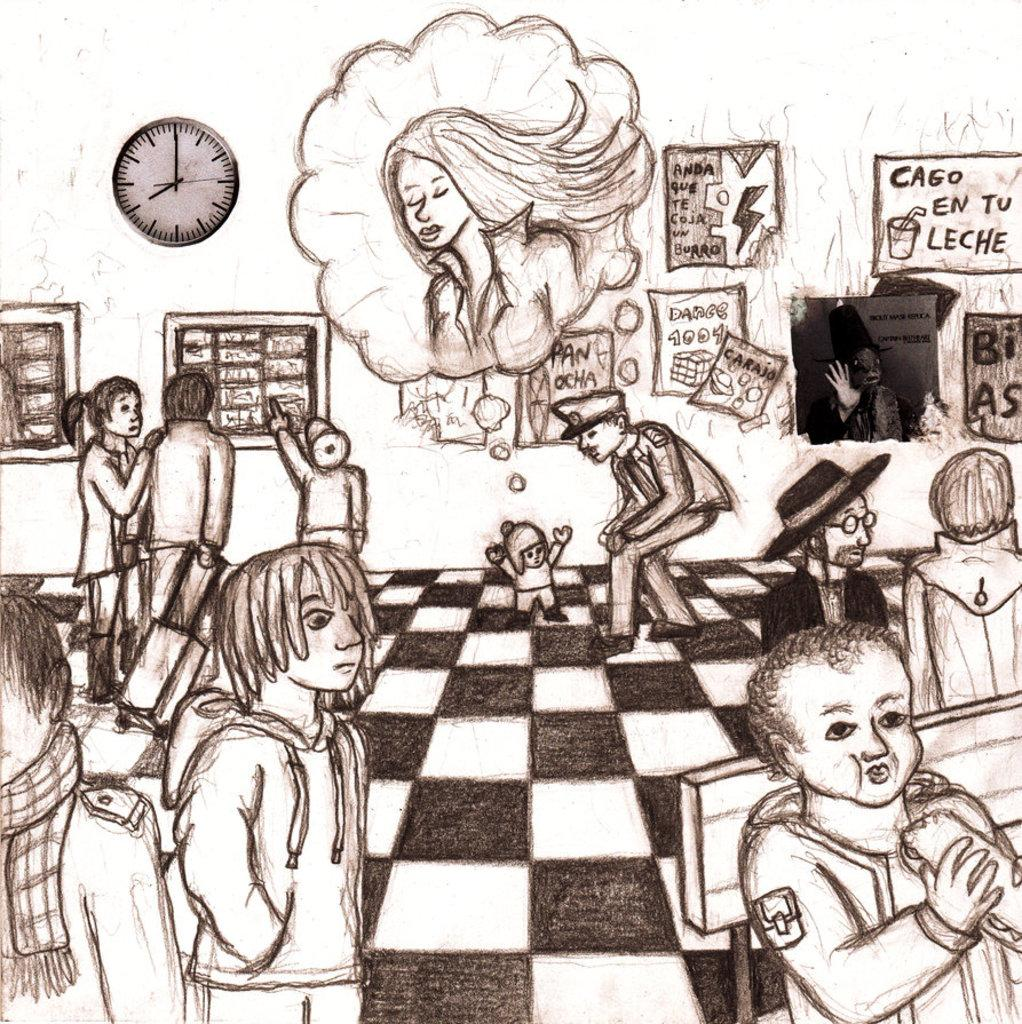<image>
Render a clear and concise summary of the photo. A pencil sketch of a police offer in a gallery talking to a small child and a sign in the background says Cago En Tu Leche. 